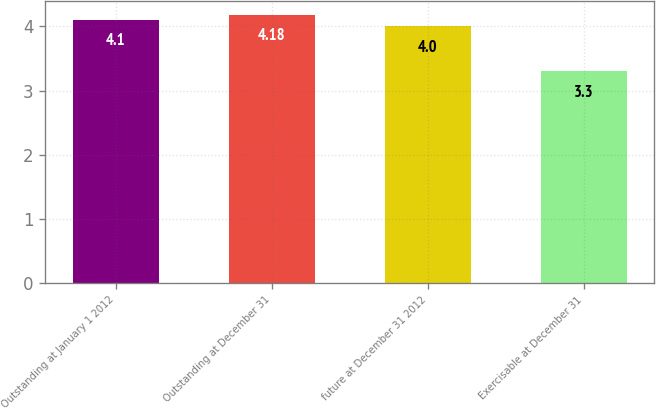<chart> <loc_0><loc_0><loc_500><loc_500><bar_chart><fcel>Outstanding at January 1 2012<fcel>Outstanding at December 31<fcel>future at December 31 2012<fcel>Exercisable at December 31<nl><fcel>4.1<fcel>4.18<fcel>4<fcel>3.3<nl></chart> 